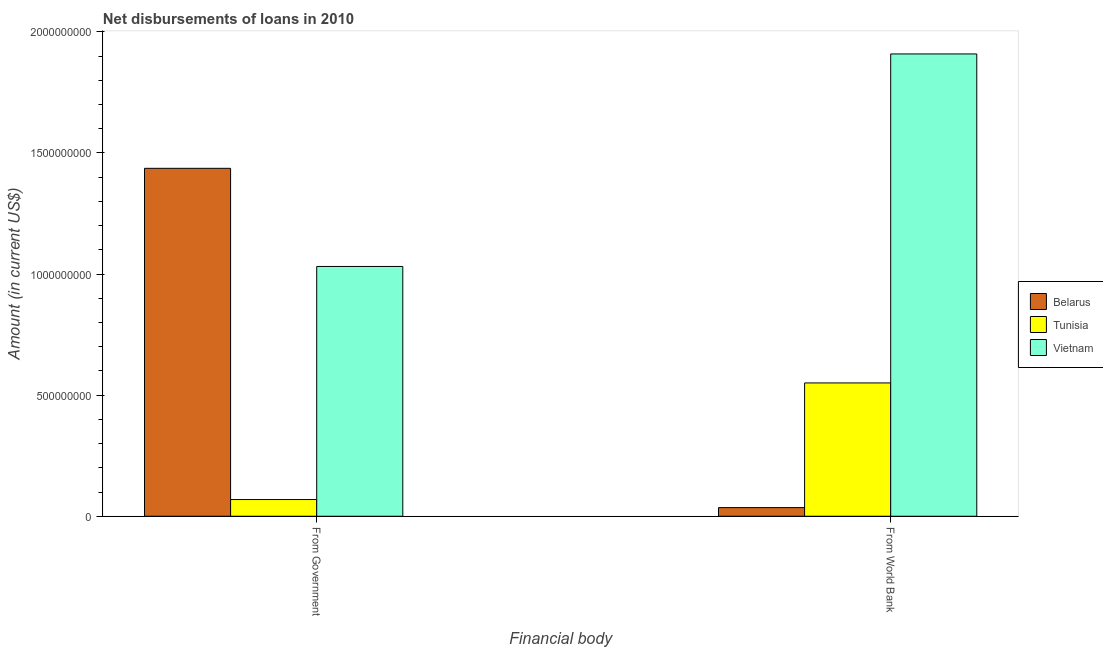How many groups of bars are there?
Your answer should be very brief. 2. How many bars are there on the 1st tick from the left?
Your answer should be compact. 3. What is the label of the 1st group of bars from the left?
Give a very brief answer. From Government. What is the net disbursements of loan from government in Vietnam?
Provide a succinct answer. 1.03e+09. Across all countries, what is the maximum net disbursements of loan from government?
Your response must be concise. 1.44e+09. Across all countries, what is the minimum net disbursements of loan from government?
Your answer should be compact. 6.90e+07. In which country was the net disbursements of loan from government maximum?
Provide a succinct answer. Belarus. In which country was the net disbursements of loan from government minimum?
Ensure brevity in your answer.  Tunisia. What is the total net disbursements of loan from world bank in the graph?
Your answer should be very brief. 2.49e+09. What is the difference between the net disbursements of loan from world bank in Belarus and that in Tunisia?
Ensure brevity in your answer.  -5.15e+08. What is the difference between the net disbursements of loan from government in Vietnam and the net disbursements of loan from world bank in Tunisia?
Your answer should be compact. 4.81e+08. What is the average net disbursements of loan from government per country?
Your answer should be compact. 8.46e+08. What is the difference between the net disbursements of loan from world bank and net disbursements of loan from government in Vietnam?
Keep it short and to the point. 8.77e+08. What is the ratio of the net disbursements of loan from government in Vietnam to that in Belarus?
Your answer should be compact. 0.72. Is the net disbursements of loan from government in Vietnam less than that in Belarus?
Your answer should be compact. Yes. What does the 2nd bar from the left in From World Bank represents?
Keep it short and to the point. Tunisia. What does the 2nd bar from the right in From Government represents?
Your answer should be very brief. Tunisia. How many bars are there?
Provide a succinct answer. 6. Are all the bars in the graph horizontal?
Make the answer very short. No. How many countries are there in the graph?
Give a very brief answer. 3. What is the difference between two consecutive major ticks on the Y-axis?
Offer a terse response. 5.00e+08. Where does the legend appear in the graph?
Keep it short and to the point. Center right. What is the title of the graph?
Offer a terse response. Net disbursements of loans in 2010. What is the label or title of the X-axis?
Your answer should be very brief. Financial body. What is the label or title of the Y-axis?
Make the answer very short. Amount (in current US$). What is the Amount (in current US$) of Belarus in From Government?
Give a very brief answer. 1.44e+09. What is the Amount (in current US$) of Tunisia in From Government?
Provide a short and direct response. 6.90e+07. What is the Amount (in current US$) of Vietnam in From Government?
Keep it short and to the point. 1.03e+09. What is the Amount (in current US$) of Belarus in From World Bank?
Your response must be concise. 3.57e+07. What is the Amount (in current US$) in Tunisia in From World Bank?
Ensure brevity in your answer.  5.50e+08. What is the Amount (in current US$) of Vietnam in From World Bank?
Offer a terse response. 1.91e+09. Across all Financial body, what is the maximum Amount (in current US$) of Belarus?
Offer a terse response. 1.44e+09. Across all Financial body, what is the maximum Amount (in current US$) in Tunisia?
Keep it short and to the point. 5.50e+08. Across all Financial body, what is the maximum Amount (in current US$) in Vietnam?
Provide a succinct answer. 1.91e+09. Across all Financial body, what is the minimum Amount (in current US$) of Belarus?
Offer a very short reply. 3.57e+07. Across all Financial body, what is the minimum Amount (in current US$) in Tunisia?
Give a very brief answer. 6.90e+07. Across all Financial body, what is the minimum Amount (in current US$) in Vietnam?
Give a very brief answer. 1.03e+09. What is the total Amount (in current US$) in Belarus in the graph?
Give a very brief answer. 1.47e+09. What is the total Amount (in current US$) in Tunisia in the graph?
Give a very brief answer. 6.19e+08. What is the total Amount (in current US$) in Vietnam in the graph?
Ensure brevity in your answer.  2.94e+09. What is the difference between the Amount (in current US$) of Belarus in From Government and that in From World Bank?
Make the answer very short. 1.40e+09. What is the difference between the Amount (in current US$) of Tunisia in From Government and that in From World Bank?
Offer a very short reply. -4.81e+08. What is the difference between the Amount (in current US$) in Vietnam in From Government and that in From World Bank?
Your answer should be compact. -8.77e+08. What is the difference between the Amount (in current US$) in Belarus in From Government and the Amount (in current US$) in Tunisia in From World Bank?
Offer a very short reply. 8.86e+08. What is the difference between the Amount (in current US$) of Belarus in From Government and the Amount (in current US$) of Vietnam in From World Bank?
Ensure brevity in your answer.  -4.72e+08. What is the difference between the Amount (in current US$) in Tunisia in From Government and the Amount (in current US$) in Vietnam in From World Bank?
Offer a terse response. -1.84e+09. What is the average Amount (in current US$) of Belarus per Financial body?
Provide a succinct answer. 7.36e+08. What is the average Amount (in current US$) of Tunisia per Financial body?
Ensure brevity in your answer.  3.10e+08. What is the average Amount (in current US$) in Vietnam per Financial body?
Keep it short and to the point. 1.47e+09. What is the difference between the Amount (in current US$) of Belarus and Amount (in current US$) of Tunisia in From Government?
Your response must be concise. 1.37e+09. What is the difference between the Amount (in current US$) in Belarus and Amount (in current US$) in Vietnam in From Government?
Your response must be concise. 4.05e+08. What is the difference between the Amount (in current US$) in Tunisia and Amount (in current US$) in Vietnam in From Government?
Your answer should be compact. -9.62e+08. What is the difference between the Amount (in current US$) in Belarus and Amount (in current US$) in Tunisia in From World Bank?
Keep it short and to the point. -5.15e+08. What is the difference between the Amount (in current US$) of Belarus and Amount (in current US$) of Vietnam in From World Bank?
Provide a short and direct response. -1.87e+09. What is the difference between the Amount (in current US$) in Tunisia and Amount (in current US$) in Vietnam in From World Bank?
Your answer should be compact. -1.36e+09. What is the ratio of the Amount (in current US$) in Belarus in From Government to that in From World Bank?
Provide a short and direct response. 40.23. What is the ratio of the Amount (in current US$) in Tunisia in From Government to that in From World Bank?
Your answer should be very brief. 0.13. What is the ratio of the Amount (in current US$) of Vietnam in From Government to that in From World Bank?
Make the answer very short. 0.54. What is the difference between the highest and the second highest Amount (in current US$) of Belarus?
Your answer should be very brief. 1.40e+09. What is the difference between the highest and the second highest Amount (in current US$) of Tunisia?
Your answer should be very brief. 4.81e+08. What is the difference between the highest and the second highest Amount (in current US$) in Vietnam?
Keep it short and to the point. 8.77e+08. What is the difference between the highest and the lowest Amount (in current US$) in Belarus?
Your answer should be very brief. 1.40e+09. What is the difference between the highest and the lowest Amount (in current US$) of Tunisia?
Offer a very short reply. 4.81e+08. What is the difference between the highest and the lowest Amount (in current US$) in Vietnam?
Your answer should be compact. 8.77e+08. 